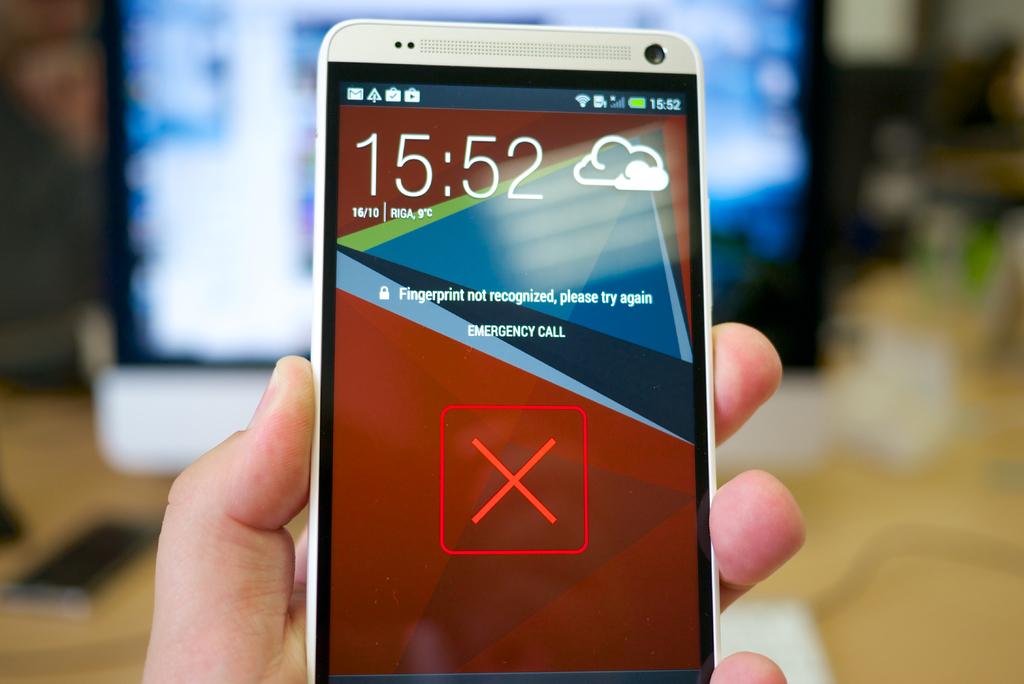What time is it?
Give a very brief answer. 15:52. What is not recognized?
Your response must be concise. Fingerprint. 